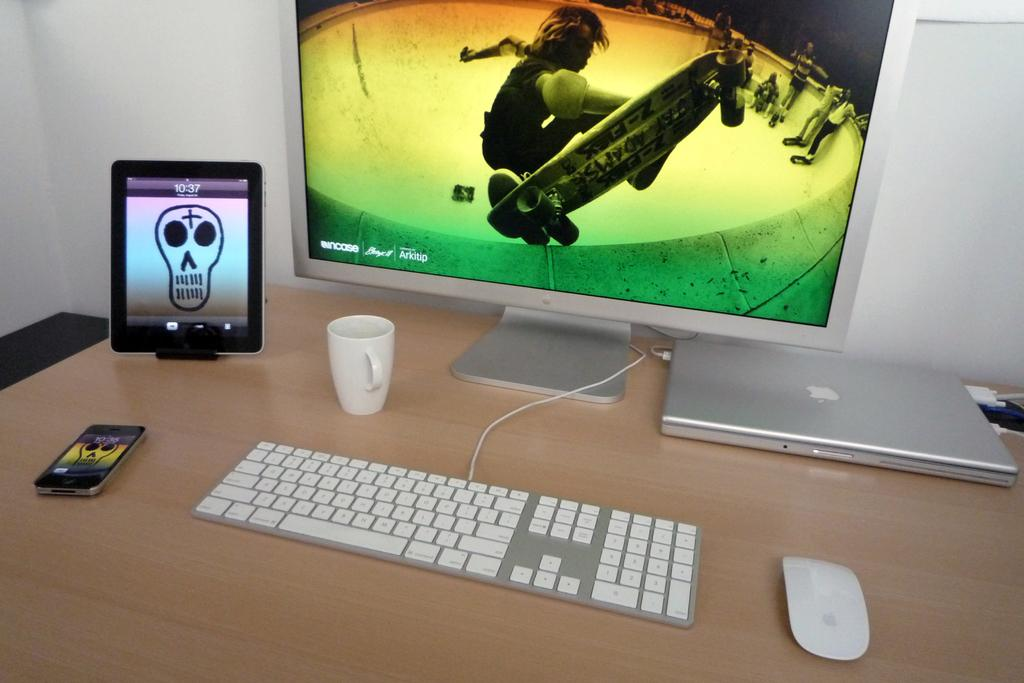<image>
Offer a succinct explanation of the picture presented. Black iPad that has the time at 10:37 next to a Mac screen. 